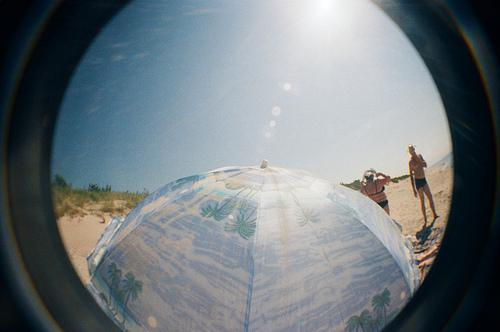Question: where is the picture taken?
Choices:
A. The forest.
B. The city.
C. The beach.
D. The desert.
Answer with the letter. Answer: C Question: how many men do you see?
Choices:
A. 1.
B. 2.
C. 0.
D. 3.
Answer with the letter. Answer: A 